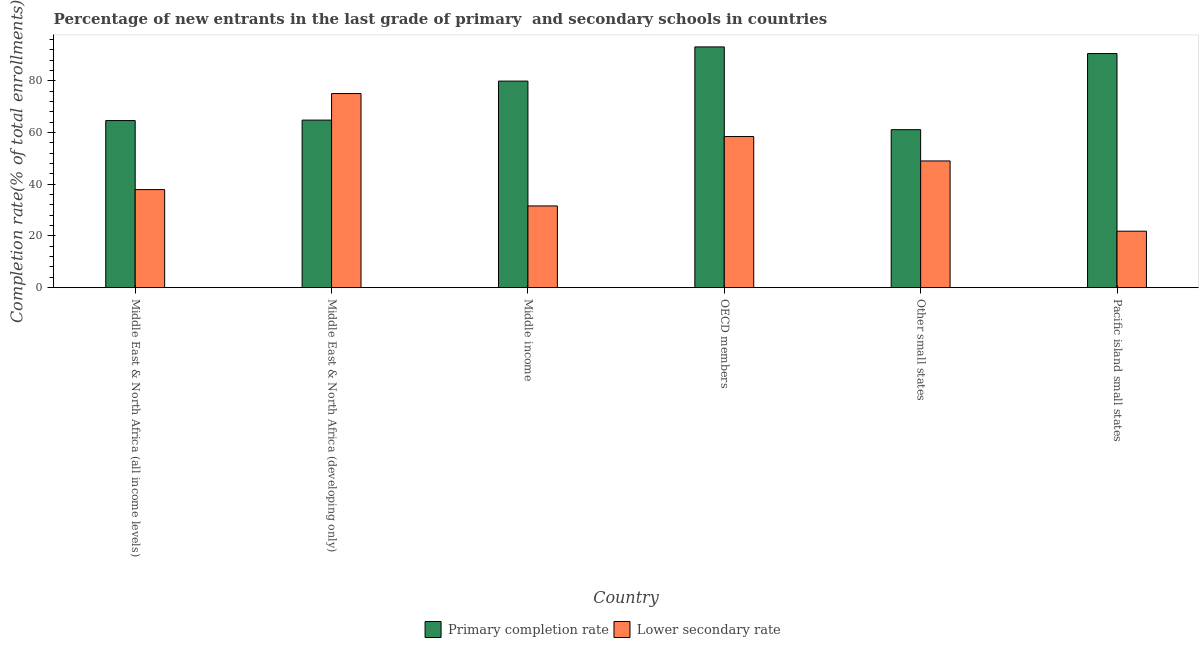How many groups of bars are there?
Offer a terse response. 6. How many bars are there on the 3rd tick from the left?
Provide a short and direct response. 2. What is the label of the 3rd group of bars from the left?
Give a very brief answer. Middle income. In how many cases, is the number of bars for a given country not equal to the number of legend labels?
Your answer should be compact. 0. What is the completion rate in primary schools in Other small states?
Your response must be concise. 61.16. Across all countries, what is the maximum completion rate in primary schools?
Ensure brevity in your answer.  93.19. Across all countries, what is the minimum completion rate in secondary schools?
Your answer should be very brief. 21.86. In which country was the completion rate in primary schools minimum?
Your response must be concise. Other small states. What is the total completion rate in secondary schools in the graph?
Give a very brief answer. 274.14. What is the difference between the completion rate in secondary schools in Middle East & North Africa (all income levels) and that in Pacific island small states?
Your answer should be compact. 16.1. What is the difference between the completion rate in primary schools in OECD members and the completion rate in secondary schools in Middle East & North Africa (all income levels)?
Give a very brief answer. 55.23. What is the average completion rate in secondary schools per country?
Ensure brevity in your answer.  45.69. What is the difference between the completion rate in secondary schools and completion rate in primary schools in Middle East & North Africa (all income levels)?
Your response must be concise. -26.72. What is the ratio of the completion rate in secondary schools in Middle income to that in Other small states?
Make the answer very short. 0.64. Is the completion rate in secondary schools in OECD members less than that in Pacific island small states?
Give a very brief answer. No. What is the difference between the highest and the second highest completion rate in secondary schools?
Make the answer very short. 16.64. What is the difference between the highest and the lowest completion rate in primary schools?
Give a very brief answer. 32.04. In how many countries, is the completion rate in secondary schools greater than the average completion rate in secondary schools taken over all countries?
Provide a short and direct response. 3. What does the 2nd bar from the left in Other small states represents?
Your answer should be compact. Lower secondary rate. What does the 1st bar from the right in Middle East & North Africa (all income levels) represents?
Give a very brief answer. Lower secondary rate. How many bars are there?
Offer a terse response. 12. Are all the bars in the graph horizontal?
Keep it short and to the point. No. Where does the legend appear in the graph?
Keep it short and to the point. Bottom center. How many legend labels are there?
Provide a succinct answer. 2. What is the title of the graph?
Offer a terse response. Percentage of new entrants in the last grade of primary  and secondary schools in countries. Does "Fraud firms" appear as one of the legend labels in the graph?
Give a very brief answer. No. What is the label or title of the X-axis?
Your response must be concise. Country. What is the label or title of the Y-axis?
Make the answer very short. Completion rate(% of total enrollments). What is the Completion rate(% of total enrollments) in Primary completion rate in Middle East & North Africa (all income levels)?
Give a very brief answer. 64.68. What is the Completion rate(% of total enrollments) in Lower secondary rate in Middle East & North Africa (all income levels)?
Ensure brevity in your answer.  37.96. What is the Completion rate(% of total enrollments) in Primary completion rate in Middle East & North Africa (developing only)?
Your answer should be compact. 64.86. What is the Completion rate(% of total enrollments) in Lower secondary rate in Middle East & North Africa (developing only)?
Offer a very short reply. 75.14. What is the Completion rate(% of total enrollments) in Primary completion rate in Middle income?
Offer a terse response. 79.96. What is the Completion rate(% of total enrollments) in Lower secondary rate in Middle income?
Provide a short and direct response. 31.63. What is the Completion rate(% of total enrollments) in Primary completion rate in OECD members?
Keep it short and to the point. 93.19. What is the Completion rate(% of total enrollments) in Lower secondary rate in OECD members?
Keep it short and to the point. 58.5. What is the Completion rate(% of total enrollments) in Primary completion rate in Other small states?
Keep it short and to the point. 61.16. What is the Completion rate(% of total enrollments) of Lower secondary rate in Other small states?
Provide a short and direct response. 49.05. What is the Completion rate(% of total enrollments) of Primary completion rate in Pacific island small states?
Offer a terse response. 90.62. What is the Completion rate(% of total enrollments) of Lower secondary rate in Pacific island small states?
Ensure brevity in your answer.  21.86. Across all countries, what is the maximum Completion rate(% of total enrollments) in Primary completion rate?
Your response must be concise. 93.19. Across all countries, what is the maximum Completion rate(% of total enrollments) in Lower secondary rate?
Give a very brief answer. 75.14. Across all countries, what is the minimum Completion rate(% of total enrollments) in Primary completion rate?
Provide a succinct answer. 61.16. Across all countries, what is the minimum Completion rate(% of total enrollments) in Lower secondary rate?
Provide a succinct answer. 21.86. What is the total Completion rate(% of total enrollments) in Primary completion rate in the graph?
Ensure brevity in your answer.  454.47. What is the total Completion rate(% of total enrollments) in Lower secondary rate in the graph?
Your response must be concise. 274.14. What is the difference between the Completion rate(% of total enrollments) of Primary completion rate in Middle East & North Africa (all income levels) and that in Middle East & North Africa (developing only)?
Provide a short and direct response. -0.18. What is the difference between the Completion rate(% of total enrollments) in Lower secondary rate in Middle East & North Africa (all income levels) and that in Middle East & North Africa (developing only)?
Your answer should be compact. -37.18. What is the difference between the Completion rate(% of total enrollments) of Primary completion rate in Middle East & North Africa (all income levels) and that in Middle income?
Your answer should be compact. -15.27. What is the difference between the Completion rate(% of total enrollments) of Lower secondary rate in Middle East & North Africa (all income levels) and that in Middle income?
Make the answer very short. 6.33. What is the difference between the Completion rate(% of total enrollments) in Primary completion rate in Middle East & North Africa (all income levels) and that in OECD members?
Provide a short and direct response. -28.51. What is the difference between the Completion rate(% of total enrollments) of Lower secondary rate in Middle East & North Africa (all income levels) and that in OECD members?
Your answer should be very brief. -20.54. What is the difference between the Completion rate(% of total enrollments) of Primary completion rate in Middle East & North Africa (all income levels) and that in Other small states?
Offer a terse response. 3.53. What is the difference between the Completion rate(% of total enrollments) of Lower secondary rate in Middle East & North Africa (all income levels) and that in Other small states?
Offer a very short reply. -11.09. What is the difference between the Completion rate(% of total enrollments) in Primary completion rate in Middle East & North Africa (all income levels) and that in Pacific island small states?
Keep it short and to the point. -25.94. What is the difference between the Completion rate(% of total enrollments) of Lower secondary rate in Middle East & North Africa (all income levels) and that in Pacific island small states?
Keep it short and to the point. 16.1. What is the difference between the Completion rate(% of total enrollments) in Primary completion rate in Middle East & North Africa (developing only) and that in Middle income?
Your answer should be compact. -15.09. What is the difference between the Completion rate(% of total enrollments) of Lower secondary rate in Middle East & North Africa (developing only) and that in Middle income?
Your response must be concise. 43.51. What is the difference between the Completion rate(% of total enrollments) of Primary completion rate in Middle East & North Africa (developing only) and that in OECD members?
Your answer should be very brief. -28.33. What is the difference between the Completion rate(% of total enrollments) of Lower secondary rate in Middle East & North Africa (developing only) and that in OECD members?
Ensure brevity in your answer.  16.64. What is the difference between the Completion rate(% of total enrollments) in Primary completion rate in Middle East & North Africa (developing only) and that in Other small states?
Your answer should be very brief. 3.71. What is the difference between the Completion rate(% of total enrollments) of Lower secondary rate in Middle East & North Africa (developing only) and that in Other small states?
Give a very brief answer. 26.09. What is the difference between the Completion rate(% of total enrollments) of Primary completion rate in Middle East & North Africa (developing only) and that in Pacific island small states?
Your response must be concise. -25.76. What is the difference between the Completion rate(% of total enrollments) of Lower secondary rate in Middle East & North Africa (developing only) and that in Pacific island small states?
Make the answer very short. 53.28. What is the difference between the Completion rate(% of total enrollments) of Primary completion rate in Middle income and that in OECD members?
Your response must be concise. -13.24. What is the difference between the Completion rate(% of total enrollments) of Lower secondary rate in Middle income and that in OECD members?
Make the answer very short. -26.86. What is the difference between the Completion rate(% of total enrollments) of Primary completion rate in Middle income and that in Other small states?
Your answer should be very brief. 18.8. What is the difference between the Completion rate(% of total enrollments) of Lower secondary rate in Middle income and that in Other small states?
Keep it short and to the point. -17.42. What is the difference between the Completion rate(% of total enrollments) of Primary completion rate in Middle income and that in Pacific island small states?
Make the answer very short. -10.67. What is the difference between the Completion rate(% of total enrollments) in Lower secondary rate in Middle income and that in Pacific island small states?
Your response must be concise. 9.78. What is the difference between the Completion rate(% of total enrollments) of Primary completion rate in OECD members and that in Other small states?
Give a very brief answer. 32.04. What is the difference between the Completion rate(% of total enrollments) of Lower secondary rate in OECD members and that in Other small states?
Keep it short and to the point. 9.45. What is the difference between the Completion rate(% of total enrollments) in Primary completion rate in OECD members and that in Pacific island small states?
Your answer should be compact. 2.57. What is the difference between the Completion rate(% of total enrollments) in Lower secondary rate in OECD members and that in Pacific island small states?
Your answer should be compact. 36.64. What is the difference between the Completion rate(% of total enrollments) of Primary completion rate in Other small states and that in Pacific island small states?
Provide a succinct answer. -29.47. What is the difference between the Completion rate(% of total enrollments) in Lower secondary rate in Other small states and that in Pacific island small states?
Your answer should be compact. 27.19. What is the difference between the Completion rate(% of total enrollments) of Primary completion rate in Middle East & North Africa (all income levels) and the Completion rate(% of total enrollments) of Lower secondary rate in Middle East & North Africa (developing only)?
Your answer should be very brief. -10.46. What is the difference between the Completion rate(% of total enrollments) of Primary completion rate in Middle East & North Africa (all income levels) and the Completion rate(% of total enrollments) of Lower secondary rate in Middle income?
Offer a terse response. 33.05. What is the difference between the Completion rate(% of total enrollments) in Primary completion rate in Middle East & North Africa (all income levels) and the Completion rate(% of total enrollments) in Lower secondary rate in OECD members?
Your answer should be very brief. 6.19. What is the difference between the Completion rate(% of total enrollments) of Primary completion rate in Middle East & North Africa (all income levels) and the Completion rate(% of total enrollments) of Lower secondary rate in Other small states?
Provide a short and direct response. 15.63. What is the difference between the Completion rate(% of total enrollments) in Primary completion rate in Middle East & North Africa (all income levels) and the Completion rate(% of total enrollments) in Lower secondary rate in Pacific island small states?
Your answer should be very brief. 42.83. What is the difference between the Completion rate(% of total enrollments) in Primary completion rate in Middle East & North Africa (developing only) and the Completion rate(% of total enrollments) in Lower secondary rate in Middle income?
Your answer should be very brief. 33.23. What is the difference between the Completion rate(% of total enrollments) in Primary completion rate in Middle East & North Africa (developing only) and the Completion rate(% of total enrollments) in Lower secondary rate in OECD members?
Offer a terse response. 6.37. What is the difference between the Completion rate(% of total enrollments) in Primary completion rate in Middle East & North Africa (developing only) and the Completion rate(% of total enrollments) in Lower secondary rate in Other small states?
Ensure brevity in your answer.  15.81. What is the difference between the Completion rate(% of total enrollments) in Primary completion rate in Middle East & North Africa (developing only) and the Completion rate(% of total enrollments) in Lower secondary rate in Pacific island small states?
Keep it short and to the point. 43.01. What is the difference between the Completion rate(% of total enrollments) in Primary completion rate in Middle income and the Completion rate(% of total enrollments) in Lower secondary rate in OECD members?
Give a very brief answer. 21.46. What is the difference between the Completion rate(% of total enrollments) of Primary completion rate in Middle income and the Completion rate(% of total enrollments) of Lower secondary rate in Other small states?
Provide a succinct answer. 30.91. What is the difference between the Completion rate(% of total enrollments) of Primary completion rate in Middle income and the Completion rate(% of total enrollments) of Lower secondary rate in Pacific island small states?
Offer a terse response. 58.1. What is the difference between the Completion rate(% of total enrollments) of Primary completion rate in OECD members and the Completion rate(% of total enrollments) of Lower secondary rate in Other small states?
Keep it short and to the point. 44.14. What is the difference between the Completion rate(% of total enrollments) in Primary completion rate in OECD members and the Completion rate(% of total enrollments) in Lower secondary rate in Pacific island small states?
Ensure brevity in your answer.  71.33. What is the difference between the Completion rate(% of total enrollments) in Primary completion rate in Other small states and the Completion rate(% of total enrollments) in Lower secondary rate in Pacific island small states?
Your response must be concise. 39.3. What is the average Completion rate(% of total enrollments) of Primary completion rate per country?
Give a very brief answer. 75.75. What is the average Completion rate(% of total enrollments) in Lower secondary rate per country?
Ensure brevity in your answer.  45.69. What is the difference between the Completion rate(% of total enrollments) of Primary completion rate and Completion rate(% of total enrollments) of Lower secondary rate in Middle East & North Africa (all income levels)?
Ensure brevity in your answer.  26.72. What is the difference between the Completion rate(% of total enrollments) in Primary completion rate and Completion rate(% of total enrollments) in Lower secondary rate in Middle East & North Africa (developing only)?
Make the answer very short. -10.28. What is the difference between the Completion rate(% of total enrollments) in Primary completion rate and Completion rate(% of total enrollments) in Lower secondary rate in Middle income?
Make the answer very short. 48.32. What is the difference between the Completion rate(% of total enrollments) of Primary completion rate and Completion rate(% of total enrollments) of Lower secondary rate in OECD members?
Make the answer very short. 34.69. What is the difference between the Completion rate(% of total enrollments) of Primary completion rate and Completion rate(% of total enrollments) of Lower secondary rate in Other small states?
Your response must be concise. 12.11. What is the difference between the Completion rate(% of total enrollments) of Primary completion rate and Completion rate(% of total enrollments) of Lower secondary rate in Pacific island small states?
Your answer should be very brief. 68.77. What is the ratio of the Completion rate(% of total enrollments) of Lower secondary rate in Middle East & North Africa (all income levels) to that in Middle East & North Africa (developing only)?
Your answer should be very brief. 0.51. What is the ratio of the Completion rate(% of total enrollments) of Primary completion rate in Middle East & North Africa (all income levels) to that in Middle income?
Offer a very short reply. 0.81. What is the ratio of the Completion rate(% of total enrollments) in Lower secondary rate in Middle East & North Africa (all income levels) to that in Middle income?
Provide a short and direct response. 1.2. What is the ratio of the Completion rate(% of total enrollments) in Primary completion rate in Middle East & North Africa (all income levels) to that in OECD members?
Keep it short and to the point. 0.69. What is the ratio of the Completion rate(% of total enrollments) of Lower secondary rate in Middle East & North Africa (all income levels) to that in OECD members?
Your answer should be very brief. 0.65. What is the ratio of the Completion rate(% of total enrollments) of Primary completion rate in Middle East & North Africa (all income levels) to that in Other small states?
Provide a succinct answer. 1.06. What is the ratio of the Completion rate(% of total enrollments) in Lower secondary rate in Middle East & North Africa (all income levels) to that in Other small states?
Give a very brief answer. 0.77. What is the ratio of the Completion rate(% of total enrollments) of Primary completion rate in Middle East & North Africa (all income levels) to that in Pacific island small states?
Your response must be concise. 0.71. What is the ratio of the Completion rate(% of total enrollments) in Lower secondary rate in Middle East & North Africa (all income levels) to that in Pacific island small states?
Keep it short and to the point. 1.74. What is the ratio of the Completion rate(% of total enrollments) of Primary completion rate in Middle East & North Africa (developing only) to that in Middle income?
Provide a succinct answer. 0.81. What is the ratio of the Completion rate(% of total enrollments) in Lower secondary rate in Middle East & North Africa (developing only) to that in Middle income?
Make the answer very short. 2.38. What is the ratio of the Completion rate(% of total enrollments) in Primary completion rate in Middle East & North Africa (developing only) to that in OECD members?
Make the answer very short. 0.7. What is the ratio of the Completion rate(% of total enrollments) in Lower secondary rate in Middle East & North Africa (developing only) to that in OECD members?
Provide a short and direct response. 1.28. What is the ratio of the Completion rate(% of total enrollments) in Primary completion rate in Middle East & North Africa (developing only) to that in Other small states?
Offer a very short reply. 1.06. What is the ratio of the Completion rate(% of total enrollments) in Lower secondary rate in Middle East & North Africa (developing only) to that in Other small states?
Provide a succinct answer. 1.53. What is the ratio of the Completion rate(% of total enrollments) in Primary completion rate in Middle East & North Africa (developing only) to that in Pacific island small states?
Ensure brevity in your answer.  0.72. What is the ratio of the Completion rate(% of total enrollments) of Lower secondary rate in Middle East & North Africa (developing only) to that in Pacific island small states?
Ensure brevity in your answer.  3.44. What is the ratio of the Completion rate(% of total enrollments) of Primary completion rate in Middle income to that in OECD members?
Provide a short and direct response. 0.86. What is the ratio of the Completion rate(% of total enrollments) in Lower secondary rate in Middle income to that in OECD members?
Your answer should be very brief. 0.54. What is the ratio of the Completion rate(% of total enrollments) in Primary completion rate in Middle income to that in Other small states?
Give a very brief answer. 1.31. What is the ratio of the Completion rate(% of total enrollments) in Lower secondary rate in Middle income to that in Other small states?
Your response must be concise. 0.64. What is the ratio of the Completion rate(% of total enrollments) of Primary completion rate in Middle income to that in Pacific island small states?
Your answer should be compact. 0.88. What is the ratio of the Completion rate(% of total enrollments) in Lower secondary rate in Middle income to that in Pacific island small states?
Provide a short and direct response. 1.45. What is the ratio of the Completion rate(% of total enrollments) of Primary completion rate in OECD members to that in Other small states?
Give a very brief answer. 1.52. What is the ratio of the Completion rate(% of total enrollments) of Lower secondary rate in OECD members to that in Other small states?
Your response must be concise. 1.19. What is the ratio of the Completion rate(% of total enrollments) in Primary completion rate in OECD members to that in Pacific island small states?
Ensure brevity in your answer.  1.03. What is the ratio of the Completion rate(% of total enrollments) of Lower secondary rate in OECD members to that in Pacific island small states?
Provide a succinct answer. 2.68. What is the ratio of the Completion rate(% of total enrollments) of Primary completion rate in Other small states to that in Pacific island small states?
Provide a short and direct response. 0.67. What is the ratio of the Completion rate(% of total enrollments) of Lower secondary rate in Other small states to that in Pacific island small states?
Your answer should be very brief. 2.24. What is the difference between the highest and the second highest Completion rate(% of total enrollments) in Primary completion rate?
Ensure brevity in your answer.  2.57. What is the difference between the highest and the second highest Completion rate(% of total enrollments) in Lower secondary rate?
Provide a succinct answer. 16.64. What is the difference between the highest and the lowest Completion rate(% of total enrollments) in Primary completion rate?
Provide a short and direct response. 32.04. What is the difference between the highest and the lowest Completion rate(% of total enrollments) in Lower secondary rate?
Give a very brief answer. 53.28. 